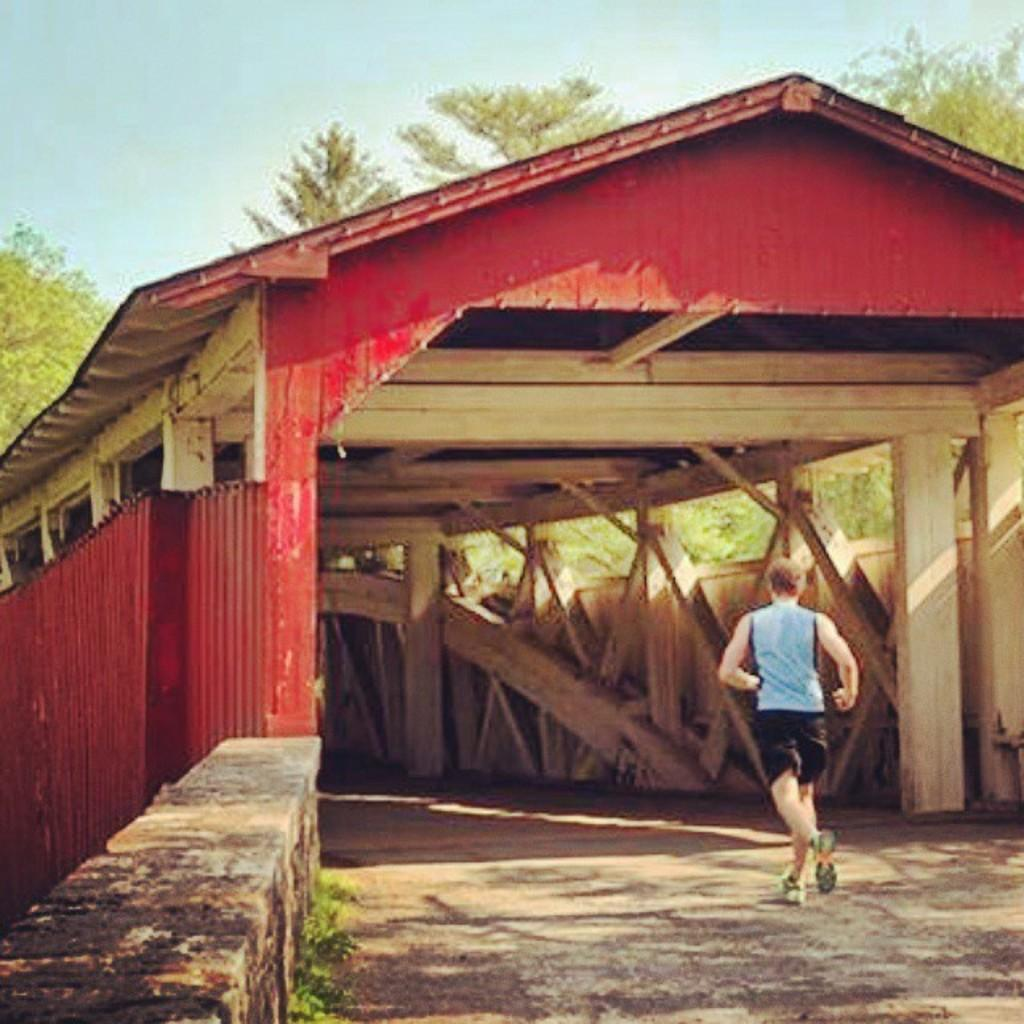What is the man in the foreground of the image doing? The man is running on the path in the foreground of the image. On which side of the path is the man running? The man is on the right side of the path. What can be seen in the middle of the image? There is a shed in the middle of the image. What is visible in the background of the image? Trees and the sky are visible in the background of the image. What type of guitar is the man playing while running in the image? There is no guitar present in the image; the man is running on the path. Can you see a pen in the man's hand while he is running in the image? There is no pen visible in the man's hand or anywhere else in the image. 